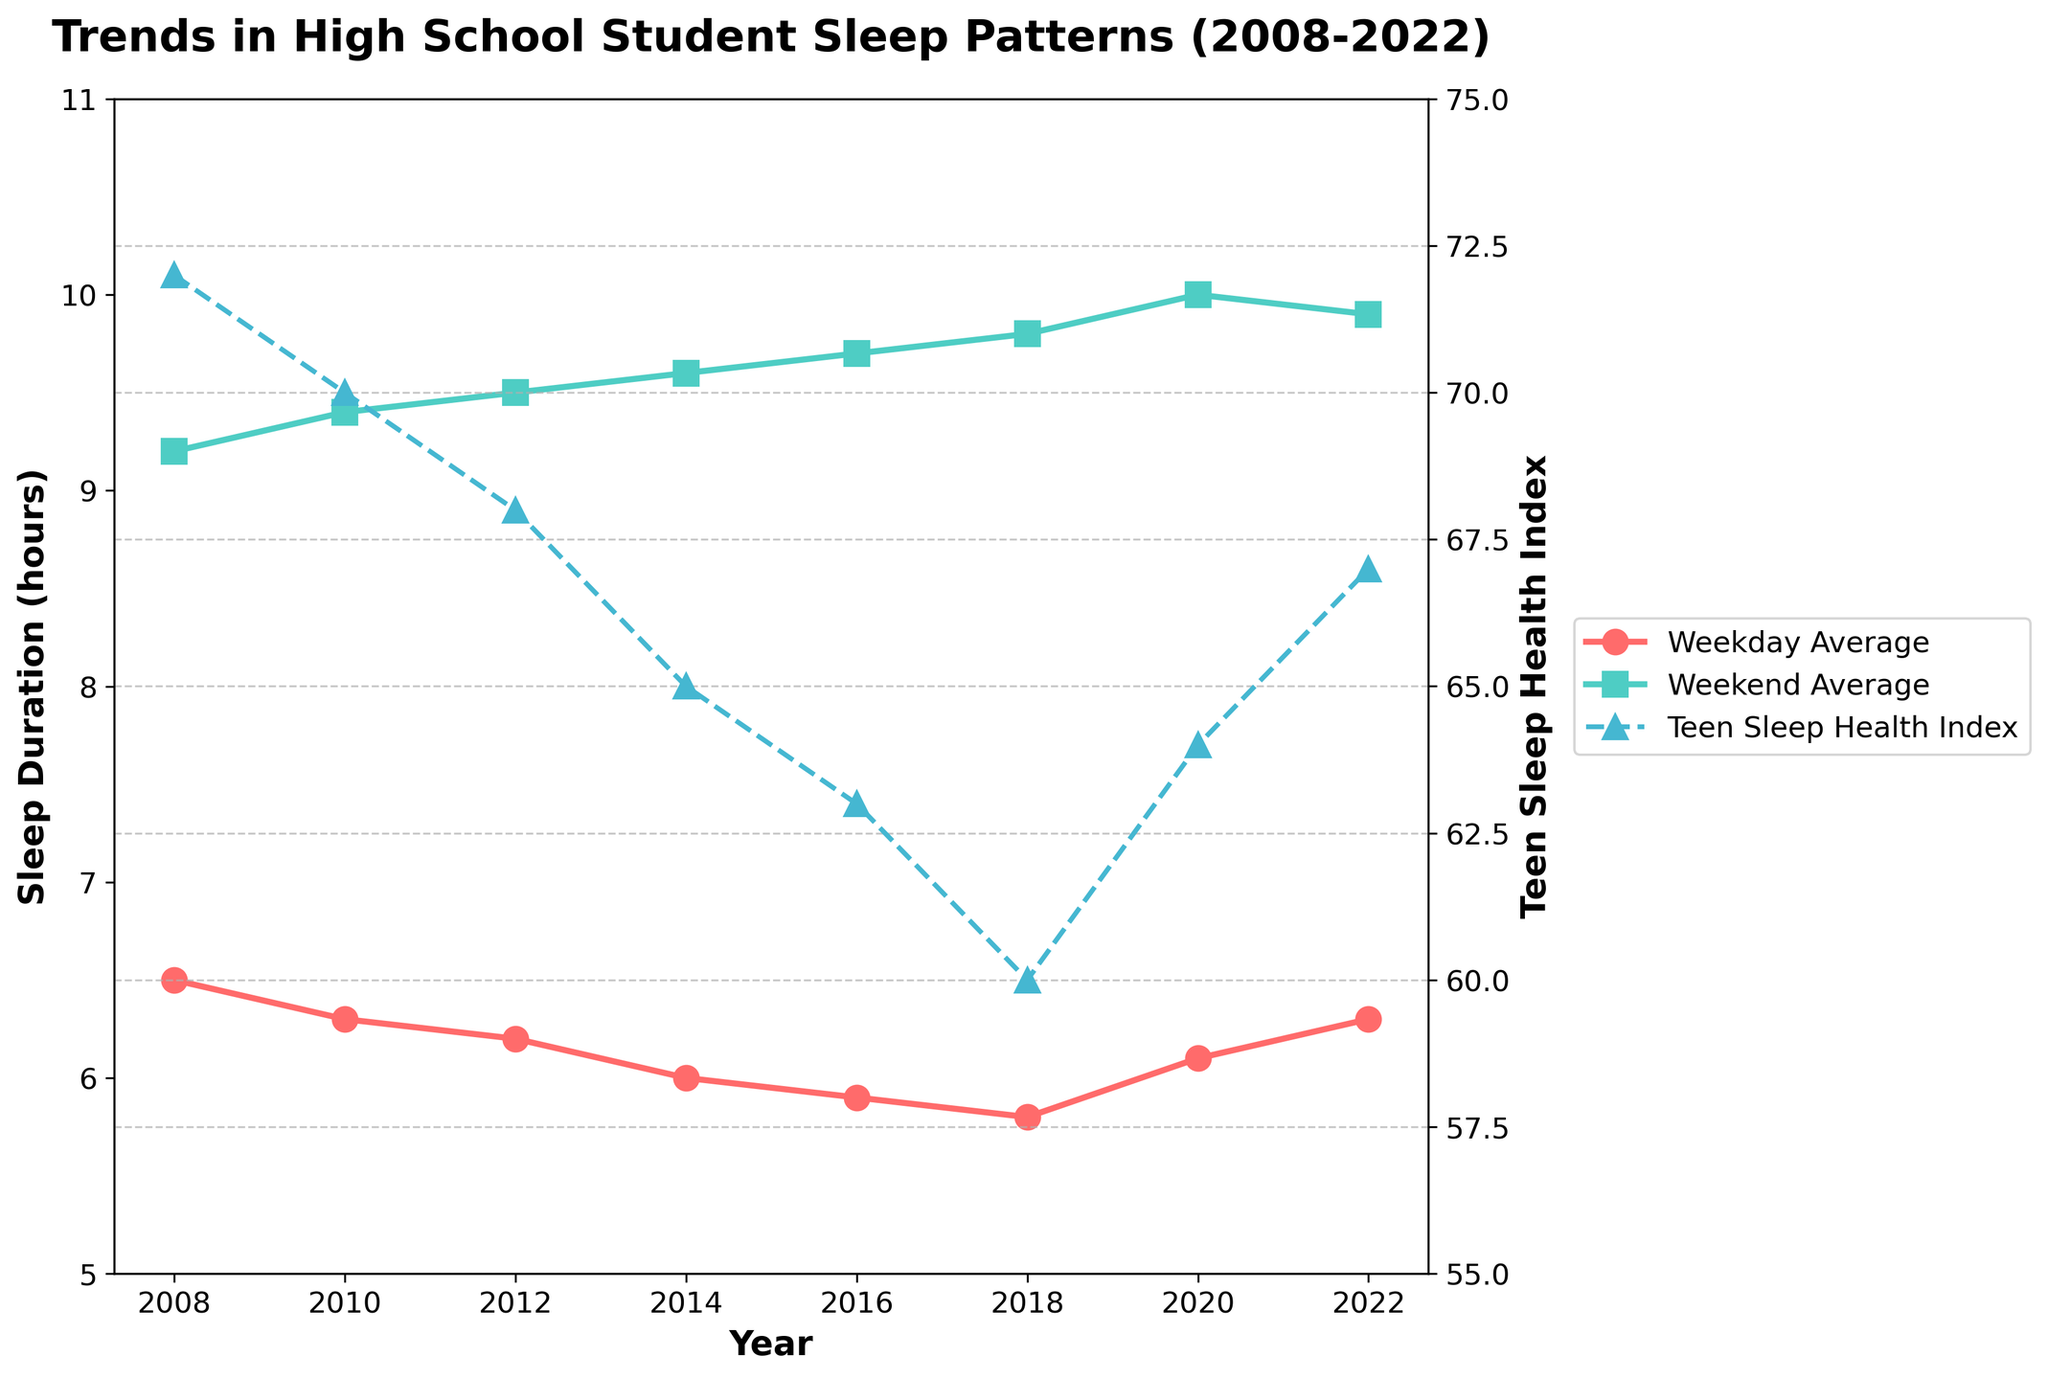What is the difference in average sleep duration between weekdays and weekends in 2012? In 2012, the weekday average sleep duration is 6.2 hours and the weekend average sleep duration is 9.5 hours. The difference is 9.5 - 6.2 = 3.3 hours
Answer: 3.3 hours How did the Trend in Teen Sleep Health Index change from 2016 to 2020? In 2016, the Teen Sleep Health Index is 63, and in 2020 it is 64. The index increased by 1 unit from 2016 to 2020
Answer: Increased by 1 unit Which year had the lowest weekday average sleep duration, and what was it? Observing the plot, the lowest weekday average sleep duration is in 2018, with a duration of 5.8 hours
Answer: 2018, 5.8 hours Compare the average weekend sleep duration between 2010 and 2022. Which year had a higher value? In 2010, the weekend average sleep duration is 9.4 hours, while in 2022 it is 9.9 hours. Therefore, 2022 had a higher value
Answer: 2022 had a higher value What was the average sleep duration on weekends over the years? The weekend sleep durations over the years are 9.2, 9.4, 9.5, 9.6, 9.7, 9.8, 10.0, and 9.9 hours. The average is (9.2 + 9.4 + 9.5 + 9.6 + 9.7 + 9.8 + 10.0 + 9.9) / 8 = 9.64 hours
Answer: 9.64 hours By how much did the Teen Sleep Health Index decrease from 2008 to 2018? In 2008, the Teen Sleep Health Index is 72, and in 2018 it is 60. The decrease is 72 - 60 = 12 units
Answer: Decreased by 12 units Is there any year where the weekday average sleep duration was more than 6.5 hours? From the visual inspection, no year shows a weekday average sleep duration exceeding 6.5 hours
Answer: No Which year saw the highest Teen Sleep Health Index, and what was the value? The highest Teen Sleep Health Index was in 2008, with a value of 72
Answer: 2008, 72 Calculate the overall difference in the weekend average sleep duration from 2008 to 2022 The weekend average sleep duration in 2008 is 9.2 hours and in 2022 is 9.9 hours. The difference is 9.9 - 9.2 = 0.7 hours
Answer: 0.7 hours How has the weekend sleep duration trend changed over the 15 years covered in the graph? Observing the plotted line for weekend sleep duration, there is a general upward trend from 9.2 hours in 2008 to 9.9 hours in 2022
Answer: Upward trend 